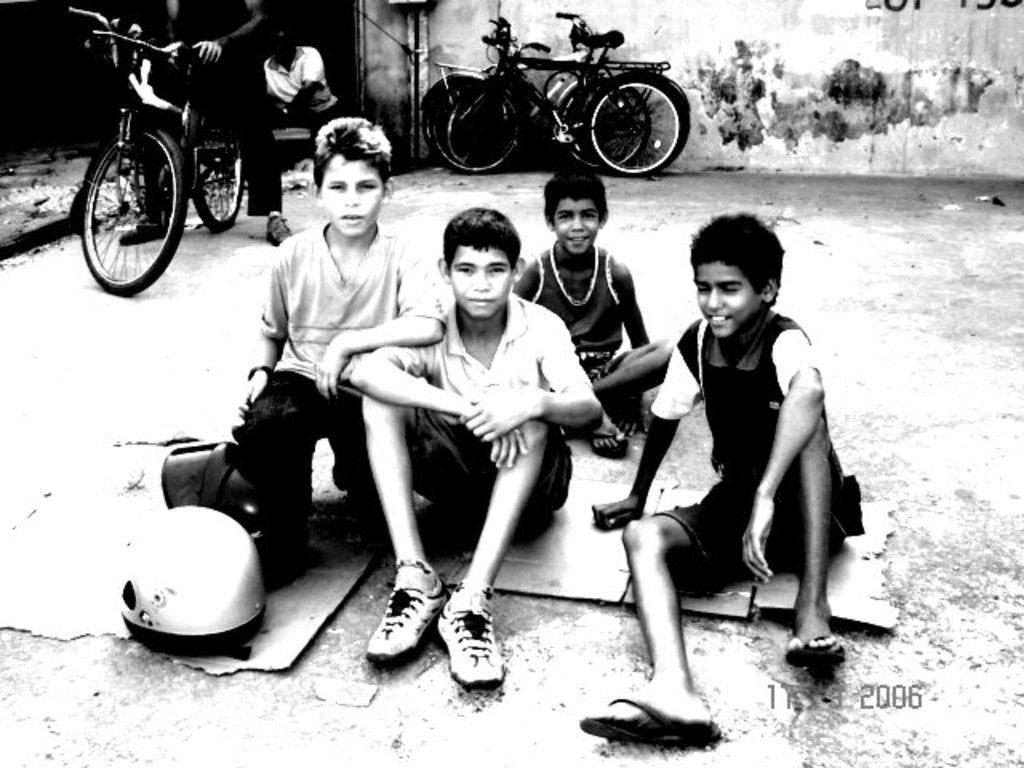Could you give a brief overview of what you see in this image? This Picture describe a old black and white photo with the group of five boys who are sitting on the road and in front there is a helmet. Behind we can see a man sitting on the bicycle and just beside him a man wearing white shirt sitting down. We can see some bicycle and white wall behind the boys. 